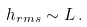<formula> <loc_0><loc_0><loc_500><loc_500>h _ { r m s } \sim L \, .</formula> 